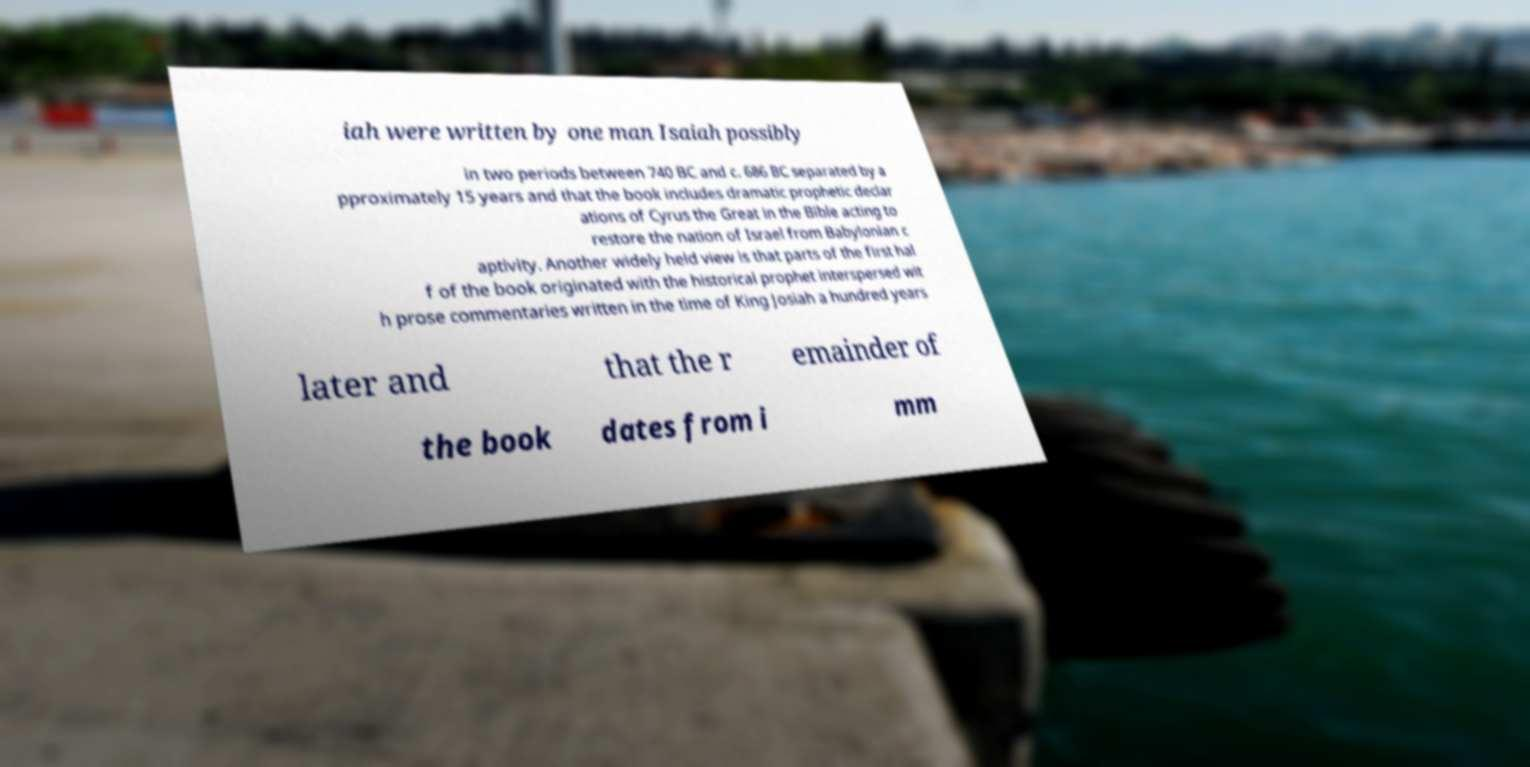Can you read and provide the text displayed in the image?This photo seems to have some interesting text. Can you extract and type it out for me? iah were written by one man Isaiah possibly in two periods between 740 BC and c. 686 BC separated by a pproximately 15 years and that the book includes dramatic prophetic declar ations of Cyrus the Great in the Bible acting to restore the nation of Israel from Babylonian c aptivity. Another widely held view is that parts of the first hal f of the book originated with the historical prophet interspersed wit h prose commentaries written in the time of King Josiah a hundred years later and that the r emainder of the book dates from i mm 